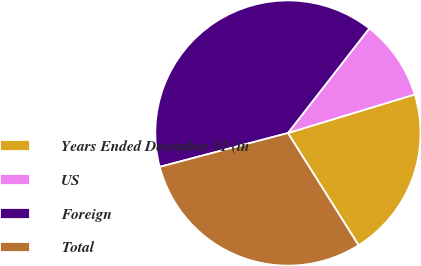Convert chart to OTSL. <chart><loc_0><loc_0><loc_500><loc_500><pie_chart><fcel>Years Ended December 31 (in<fcel>US<fcel>Foreign<fcel>Total<nl><fcel>20.76%<fcel>9.78%<fcel>39.62%<fcel>29.83%<nl></chart> 